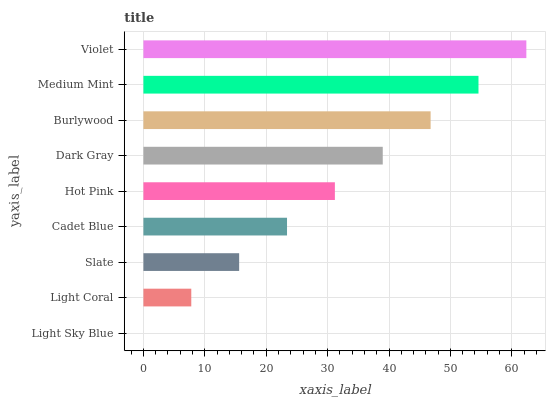Is Light Sky Blue the minimum?
Answer yes or no. Yes. Is Violet the maximum?
Answer yes or no. Yes. Is Light Coral the minimum?
Answer yes or no. No. Is Light Coral the maximum?
Answer yes or no. No. Is Light Coral greater than Light Sky Blue?
Answer yes or no. Yes. Is Light Sky Blue less than Light Coral?
Answer yes or no. Yes. Is Light Sky Blue greater than Light Coral?
Answer yes or no. No. Is Light Coral less than Light Sky Blue?
Answer yes or no. No. Is Hot Pink the high median?
Answer yes or no. Yes. Is Hot Pink the low median?
Answer yes or no. Yes. Is Slate the high median?
Answer yes or no. No. Is Cadet Blue the low median?
Answer yes or no. No. 